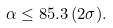<formula> <loc_0><loc_0><loc_500><loc_500>\alpha \leq 8 5 . 3 \, ( 2 \sigma ) .</formula> 